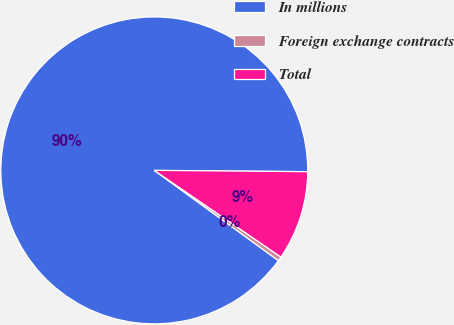Convert chart to OTSL. <chart><loc_0><loc_0><loc_500><loc_500><pie_chart><fcel>In millions<fcel>Foreign exchange contracts<fcel>Total<nl><fcel>90.14%<fcel>0.45%<fcel>9.42%<nl></chart> 